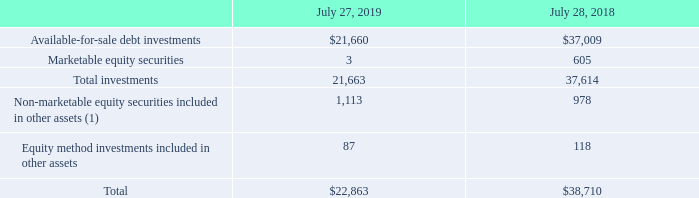9. Available-for-Sale Debt Investments and Equity Investments
The following table summarizes our available-for-sale debt investments and equity investments (in millions):
(1) We held equity interests in certain private equity funds of $0.6 billion as of July 27, 2019 which are accounted for under the NAV practical expedient following the adoption of ASU 2016-01, Financial Instruments, starting in the first quarter of fiscal 2019.
Which years does the table provide information for the company's available-for-sale debt investments and equity investments? 2019, 2018. What was the Marketable equity securities in 2018?
Answer scale should be: million. 605. What were the total investments in 2019?
Answer scale should be: million. 21,663. What was the change in the Equity method investments included in other assets between 2018 and 2019?
Answer scale should be: million. 87-118
Answer: -31. How many years did total investments exceed $30,000 million? 2018
Answer: 1. What was the percentage change in the total available-for-sale debt investments and equity investments between 2018 and 2019?
Answer scale should be: percent. (22,863-38,710)/38,710
Answer: -40.94. 